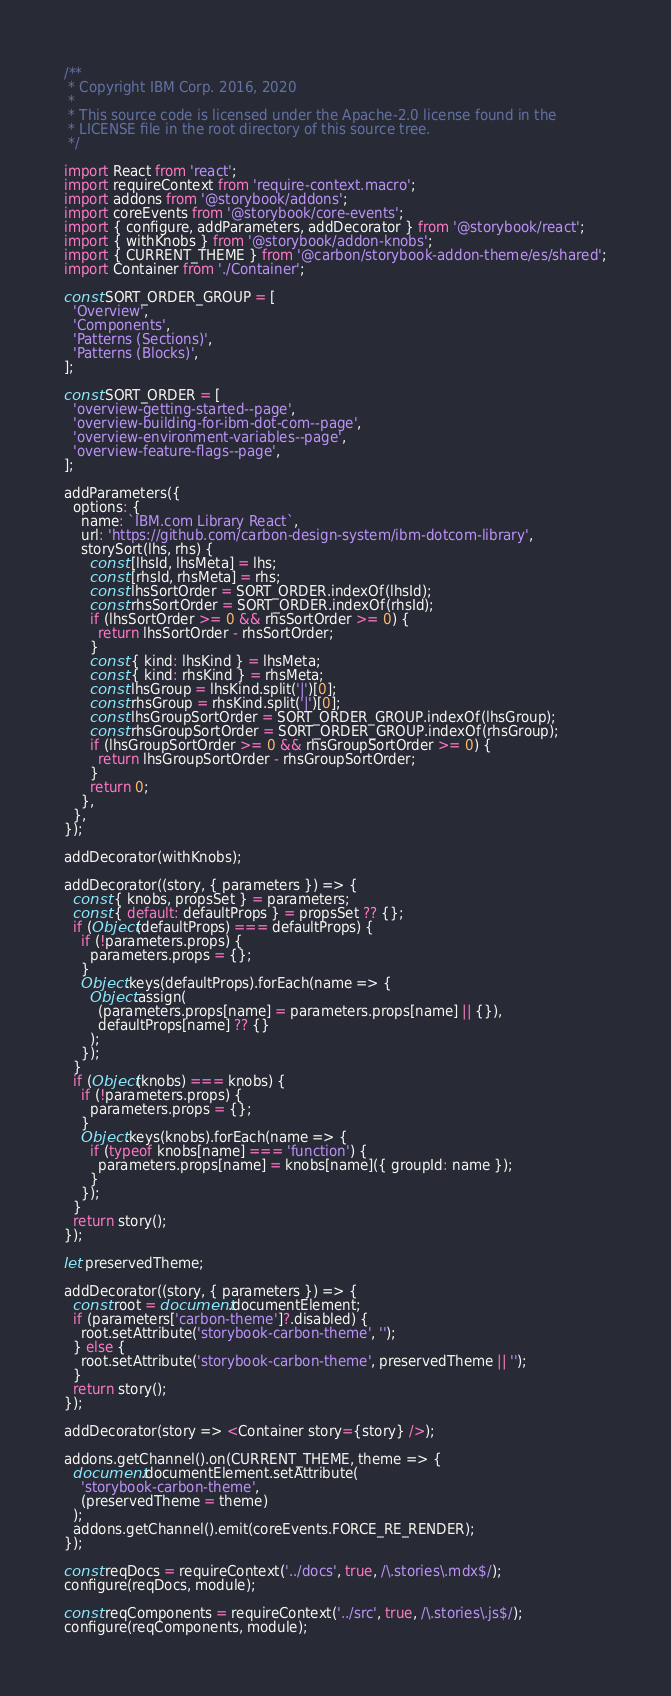<code> <loc_0><loc_0><loc_500><loc_500><_JavaScript_>/**
 * Copyright IBM Corp. 2016, 2020
 *
 * This source code is licensed under the Apache-2.0 license found in the
 * LICENSE file in the root directory of this source tree.
 */

import React from 'react';
import requireContext from 'require-context.macro';
import addons from '@storybook/addons';
import coreEvents from '@storybook/core-events';
import { configure, addParameters, addDecorator } from '@storybook/react';
import { withKnobs } from '@storybook/addon-knobs';
import { CURRENT_THEME } from '@carbon/storybook-addon-theme/es/shared';
import Container from './Container';

const SORT_ORDER_GROUP = [
  'Overview',
  'Components',
  'Patterns (Sections)',
  'Patterns (Blocks)',
];

const SORT_ORDER = [
  'overview-getting-started--page',
  'overview-building-for-ibm-dot-com--page',
  'overview-environment-variables--page',
  'overview-feature-flags--page',
];

addParameters({
  options: {
    name: `IBM.com Library React`,
    url: 'https://github.com/carbon-design-system/ibm-dotcom-library',
    storySort(lhs, rhs) {
      const [lhsId, lhsMeta] = lhs;
      const [rhsId, rhsMeta] = rhs;
      const lhsSortOrder = SORT_ORDER.indexOf(lhsId);
      const rhsSortOrder = SORT_ORDER.indexOf(rhsId);
      if (lhsSortOrder >= 0 && rhsSortOrder >= 0) {
        return lhsSortOrder - rhsSortOrder;
      }
      const { kind: lhsKind } = lhsMeta;
      const { kind: rhsKind } = rhsMeta;
      const lhsGroup = lhsKind.split('|')[0];
      const rhsGroup = rhsKind.split('|')[0];
      const lhsGroupSortOrder = SORT_ORDER_GROUP.indexOf(lhsGroup);
      const rhsGroupSortOrder = SORT_ORDER_GROUP.indexOf(rhsGroup);
      if (lhsGroupSortOrder >= 0 && rhsGroupSortOrder >= 0) {
        return lhsGroupSortOrder - rhsGroupSortOrder;
      }
      return 0;
    },
  },
});

addDecorator(withKnobs);

addDecorator((story, { parameters }) => {
  const { knobs, propsSet } = parameters;
  const { default: defaultProps } = propsSet ?? {};
  if (Object(defaultProps) === defaultProps) {
    if (!parameters.props) {
      parameters.props = {};
    }
    Object.keys(defaultProps).forEach(name => {
      Object.assign(
        (parameters.props[name] = parameters.props[name] || {}),
        defaultProps[name] ?? {}
      );
    });
  }
  if (Object(knobs) === knobs) {
    if (!parameters.props) {
      parameters.props = {};
    }
    Object.keys(knobs).forEach(name => {
      if (typeof knobs[name] === 'function') {
        parameters.props[name] = knobs[name]({ groupId: name });
      }
    });
  }
  return story();
});

let preservedTheme;

addDecorator((story, { parameters }) => {
  const root = document.documentElement;
  if (parameters['carbon-theme']?.disabled) {
    root.setAttribute('storybook-carbon-theme', '');
  } else {
    root.setAttribute('storybook-carbon-theme', preservedTheme || '');
  }
  return story();
});

addDecorator(story => <Container story={story} />);

addons.getChannel().on(CURRENT_THEME, theme => {
  document.documentElement.setAttribute(
    'storybook-carbon-theme',
    (preservedTheme = theme)
  );
  addons.getChannel().emit(coreEvents.FORCE_RE_RENDER);
});

const reqDocs = requireContext('../docs', true, /\.stories\.mdx$/);
configure(reqDocs, module);

const reqComponents = requireContext('../src', true, /\.stories\.js$/);
configure(reqComponents, module);
</code> 